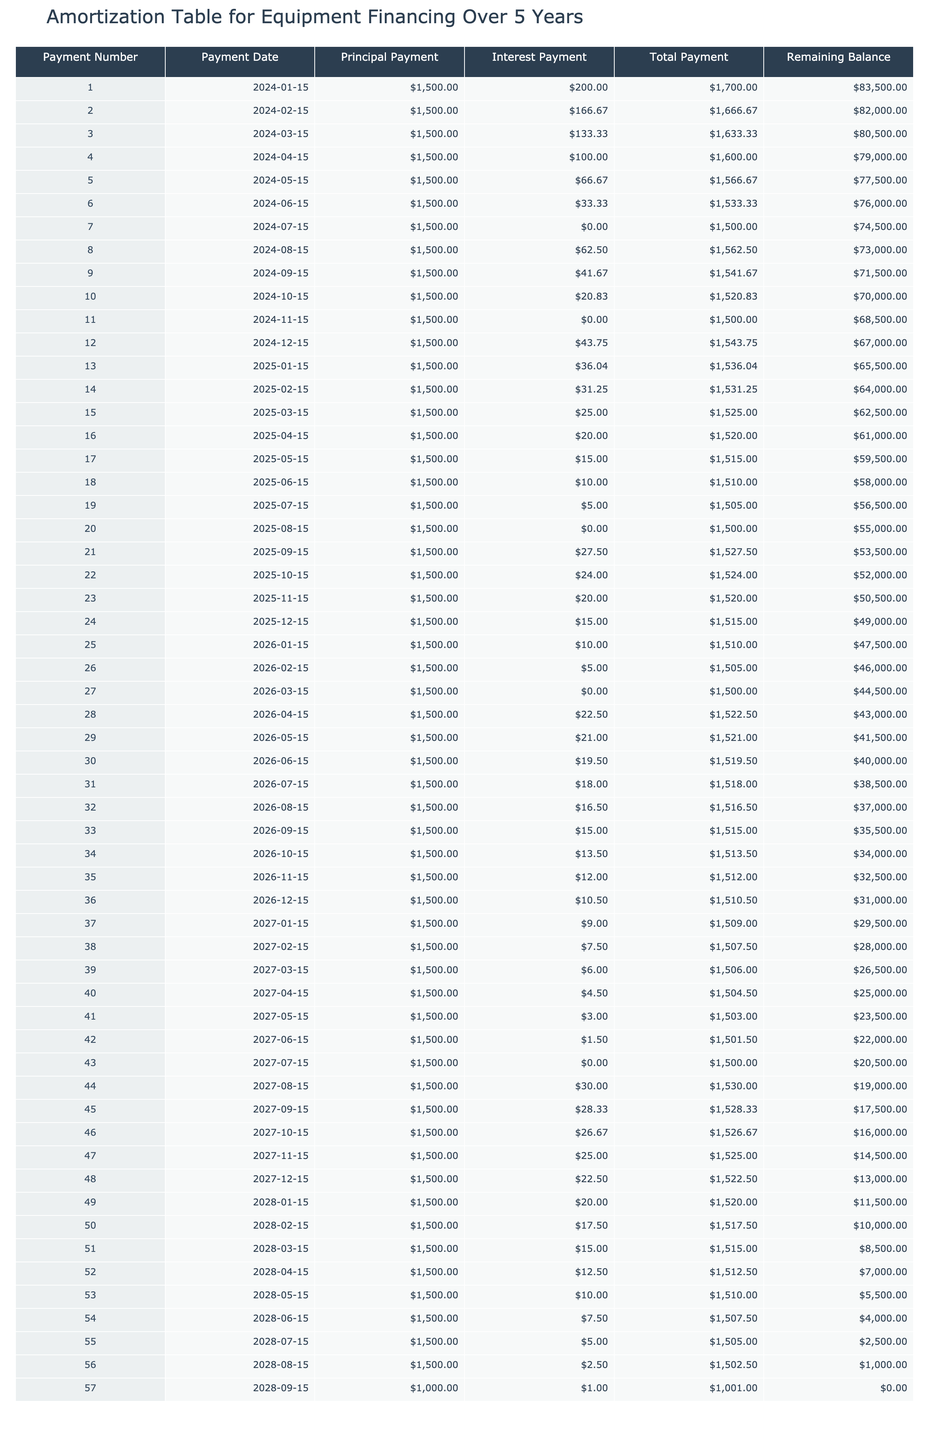What is the total payment for the first payment number? Referring to the first row of the table, the value under the "Total Payment" column for payment number 1 is $1,700.00.
Answer: $1,700.00 How much was paid in interest during the second payment? Looking at the second row, the "Interest Payment" column shows $166.67 for payment number 2.
Answer: $166.67 What is the remaining balance after the 40th payment? In the table, the "Remaining Balance" for payment number 40 is listed as $25,000.00.
Answer: $25,000.00 What is the average principal payment across the first five payments? The principal payments for the first five payments are all $1,500.00. Averaging this gives (1500 + 1500 + 1500 + 1500 + 1500) = $7,500, and dividing by 5 results in an average of $1,500.00.
Answer: $1,500.00 Is the interest payment for payment number 7 greater than the interest payment for payment number 8? The interest payment for payment number 7 is $0.00 while for payment number 8 it is $62.50. Since 0 is not greater than 62.50, the answer is no.
Answer: No What is the decrease in the remaining balance from payment number 30 to payment number 31? The remaining balance for payment number 30 is $40,000.00 and for payment number 31 is $38,500.00. The decrease is calculated as $40,000 - $38,500 = $1,500.00.
Answer: $1,500.00 Are there any payments where the interest payment is $0.00? Referring to the table, payment numbers 7 and 11 both have an interest payment of $0.00, confirming that such payments do exist.
Answer: Yes What is the total interest paid in the first year, based on the first 12 payments? The interest payments for the first year (payments 1 to 12) are $200.00, $166.67, $133.33, $100.00, $66.67, $33.33, $0.00, $62.50, $41.67, $20.83, $0.00, and $43.75. Adding these gives a total of $200 + 166.67 + 133.33 + 100 + 66.67 + 33.33 + 0 + 62.50 + 41.67 + 20.83 + 0 + 43.75 = $894.33.
Answer: $894.33 What are the total payments made during the last six months of the loan? The total payments for the last six payments (payments 52 to 57) are $1,512.50, $1,517.50, $1,515.00, $1,500.00, $1,530.00, and $1,528.33. Summing these yields $1,512.50 + $1,517.50 + $1,515.00 + $1,500.00 + $1,530.00 + $1,528.33 = $9,603.33.
Answer: $9,603.33 